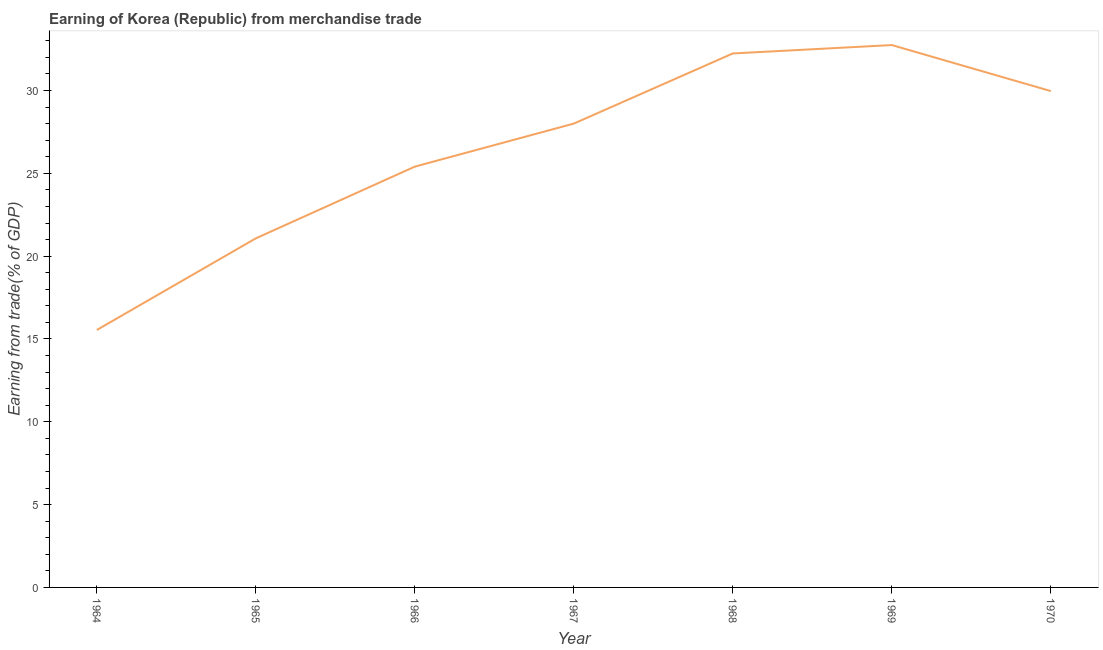What is the earning from merchandise trade in 1969?
Your answer should be compact. 32.75. Across all years, what is the maximum earning from merchandise trade?
Keep it short and to the point. 32.75. Across all years, what is the minimum earning from merchandise trade?
Provide a short and direct response. 15.54. In which year was the earning from merchandise trade maximum?
Your response must be concise. 1969. In which year was the earning from merchandise trade minimum?
Your response must be concise. 1964. What is the sum of the earning from merchandise trade?
Make the answer very short. 184.99. What is the difference between the earning from merchandise trade in 1965 and 1967?
Give a very brief answer. -6.93. What is the average earning from merchandise trade per year?
Offer a very short reply. 26.43. What is the median earning from merchandise trade?
Your answer should be compact. 28. What is the ratio of the earning from merchandise trade in 1964 to that in 1965?
Provide a short and direct response. 0.74. What is the difference between the highest and the second highest earning from merchandise trade?
Provide a short and direct response. 0.51. What is the difference between the highest and the lowest earning from merchandise trade?
Your answer should be very brief. 17.2. Does the earning from merchandise trade monotonically increase over the years?
Your answer should be compact. No. Are the values on the major ticks of Y-axis written in scientific E-notation?
Provide a succinct answer. No. Does the graph contain any zero values?
Offer a terse response. No. What is the title of the graph?
Provide a short and direct response. Earning of Korea (Republic) from merchandise trade. What is the label or title of the Y-axis?
Your answer should be very brief. Earning from trade(% of GDP). What is the Earning from trade(% of GDP) of 1964?
Ensure brevity in your answer.  15.54. What is the Earning from trade(% of GDP) in 1965?
Provide a short and direct response. 21.08. What is the Earning from trade(% of GDP) of 1966?
Your answer should be compact. 25.41. What is the Earning from trade(% of GDP) of 1967?
Provide a short and direct response. 28. What is the Earning from trade(% of GDP) in 1968?
Your response must be concise. 32.24. What is the Earning from trade(% of GDP) of 1969?
Offer a terse response. 32.75. What is the Earning from trade(% of GDP) in 1970?
Your answer should be compact. 29.97. What is the difference between the Earning from trade(% of GDP) in 1964 and 1965?
Offer a terse response. -5.53. What is the difference between the Earning from trade(% of GDP) in 1964 and 1966?
Make the answer very short. -9.86. What is the difference between the Earning from trade(% of GDP) in 1964 and 1967?
Ensure brevity in your answer.  -12.46. What is the difference between the Earning from trade(% of GDP) in 1964 and 1968?
Give a very brief answer. -16.7. What is the difference between the Earning from trade(% of GDP) in 1964 and 1969?
Provide a succinct answer. -17.2. What is the difference between the Earning from trade(% of GDP) in 1964 and 1970?
Provide a succinct answer. -14.42. What is the difference between the Earning from trade(% of GDP) in 1965 and 1966?
Offer a terse response. -4.33. What is the difference between the Earning from trade(% of GDP) in 1965 and 1967?
Make the answer very short. -6.93. What is the difference between the Earning from trade(% of GDP) in 1965 and 1968?
Make the answer very short. -11.16. What is the difference between the Earning from trade(% of GDP) in 1965 and 1969?
Your answer should be compact. -11.67. What is the difference between the Earning from trade(% of GDP) in 1965 and 1970?
Give a very brief answer. -8.89. What is the difference between the Earning from trade(% of GDP) in 1966 and 1967?
Provide a succinct answer. -2.6. What is the difference between the Earning from trade(% of GDP) in 1966 and 1968?
Make the answer very short. -6.83. What is the difference between the Earning from trade(% of GDP) in 1966 and 1969?
Make the answer very short. -7.34. What is the difference between the Earning from trade(% of GDP) in 1966 and 1970?
Keep it short and to the point. -4.56. What is the difference between the Earning from trade(% of GDP) in 1967 and 1968?
Ensure brevity in your answer.  -4.24. What is the difference between the Earning from trade(% of GDP) in 1967 and 1969?
Provide a succinct answer. -4.74. What is the difference between the Earning from trade(% of GDP) in 1967 and 1970?
Offer a very short reply. -1.96. What is the difference between the Earning from trade(% of GDP) in 1968 and 1969?
Provide a succinct answer. -0.51. What is the difference between the Earning from trade(% of GDP) in 1968 and 1970?
Make the answer very short. 2.27. What is the difference between the Earning from trade(% of GDP) in 1969 and 1970?
Ensure brevity in your answer.  2.78. What is the ratio of the Earning from trade(% of GDP) in 1964 to that in 1965?
Offer a very short reply. 0.74. What is the ratio of the Earning from trade(% of GDP) in 1964 to that in 1966?
Your answer should be very brief. 0.61. What is the ratio of the Earning from trade(% of GDP) in 1964 to that in 1967?
Offer a very short reply. 0.56. What is the ratio of the Earning from trade(% of GDP) in 1964 to that in 1968?
Offer a very short reply. 0.48. What is the ratio of the Earning from trade(% of GDP) in 1964 to that in 1969?
Offer a terse response. 0.47. What is the ratio of the Earning from trade(% of GDP) in 1964 to that in 1970?
Ensure brevity in your answer.  0.52. What is the ratio of the Earning from trade(% of GDP) in 1965 to that in 1966?
Provide a short and direct response. 0.83. What is the ratio of the Earning from trade(% of GDP) in 1965 to that in 1967?
Keep it short and to the point. 0.75. What is the ratio of the Earning from trade(% of GDP) in 1965 to that in 1968?
Give a very brief answer. 0.65. What is the ratio of the Earning from trade(% of GDP) in 1965 to that in 1969?
Make the answer very short. 0.64. What is the ratio of the Earning from trade(% of GDP) in 1965 to that in 1970?
Make the answer very short. 0.7. What is the ratio of the Earning from trade(% of GDP) in 1966 to that in 1967?
Provide a succinct answer. 0.91. What is the ratio of the Earning from trade(% of GDP) in 1966 to that in 1968?
Provide a short and direct response. 0.79. What is the ratio of the Earning from trade(% of GDP) in 1966 to that in 1969?
Offer a very short reply. 0.78. What is the ratio of the Earning from trade(% of GDP) in 1966 to that in 1970?
Your response must be concise. 0.85. What is the ratio of the Earning from trade(% of GDP) in 1967 to that in 1968?
Give a very brief answer. 0.87. What is the ratio of the Earning from trade(% of GDP) in 1967 to that in 1969?
Keep it short and to the point. 0.85. What is the ratio of the Earning from trade(% of GDP) in 1967 to that in 1970?
Your answer should be compact. 0.93. What is the ratio of the Earning from trade(% of GDP) in 1968 to that in 1969?
Give a very brief answer. 0.98. What is the ratio of the Earning from trade(% of GDP) in 1968 to that in 1970?
Make the answer very short. 1.08. What is the ratio of the Earning from trade(% of GDP) in 1969 to that in 1970?
Ensure brevity in your answer.  1.09. 